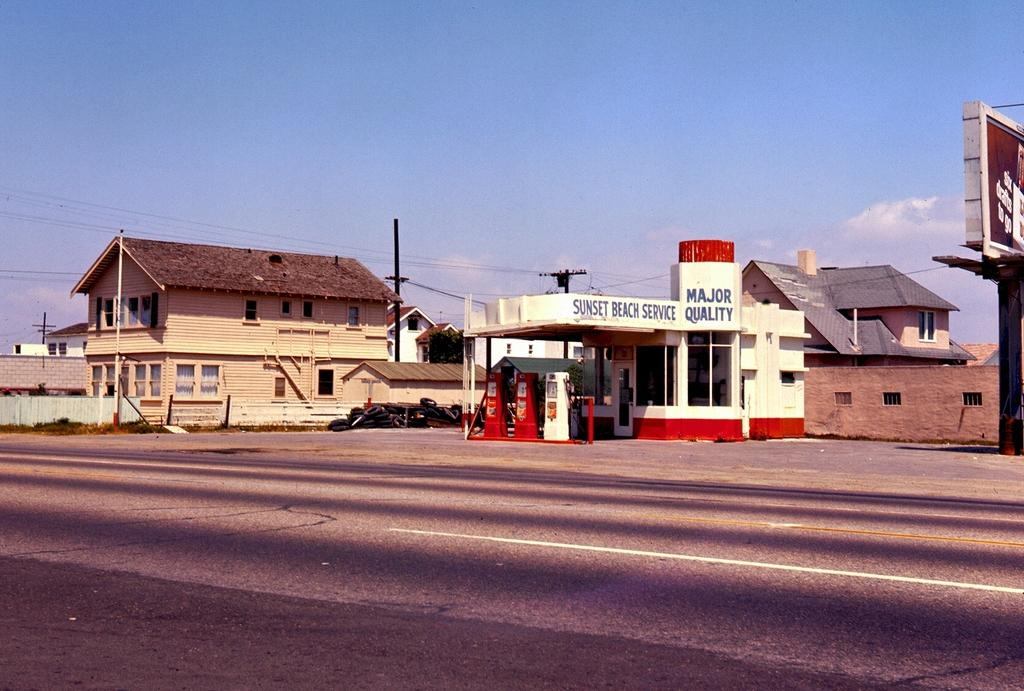What is the main feature of the image? There is a road in the image. What can be seen in the background of the image? There is a gas station, houses, current poles, and the sky visible in the background of the image. How many letters does the beggar on the page hold in the image? There is no beggar or page present in the image. What type of page is the beggar reading in the image? There is no beggar or page present in the image. 